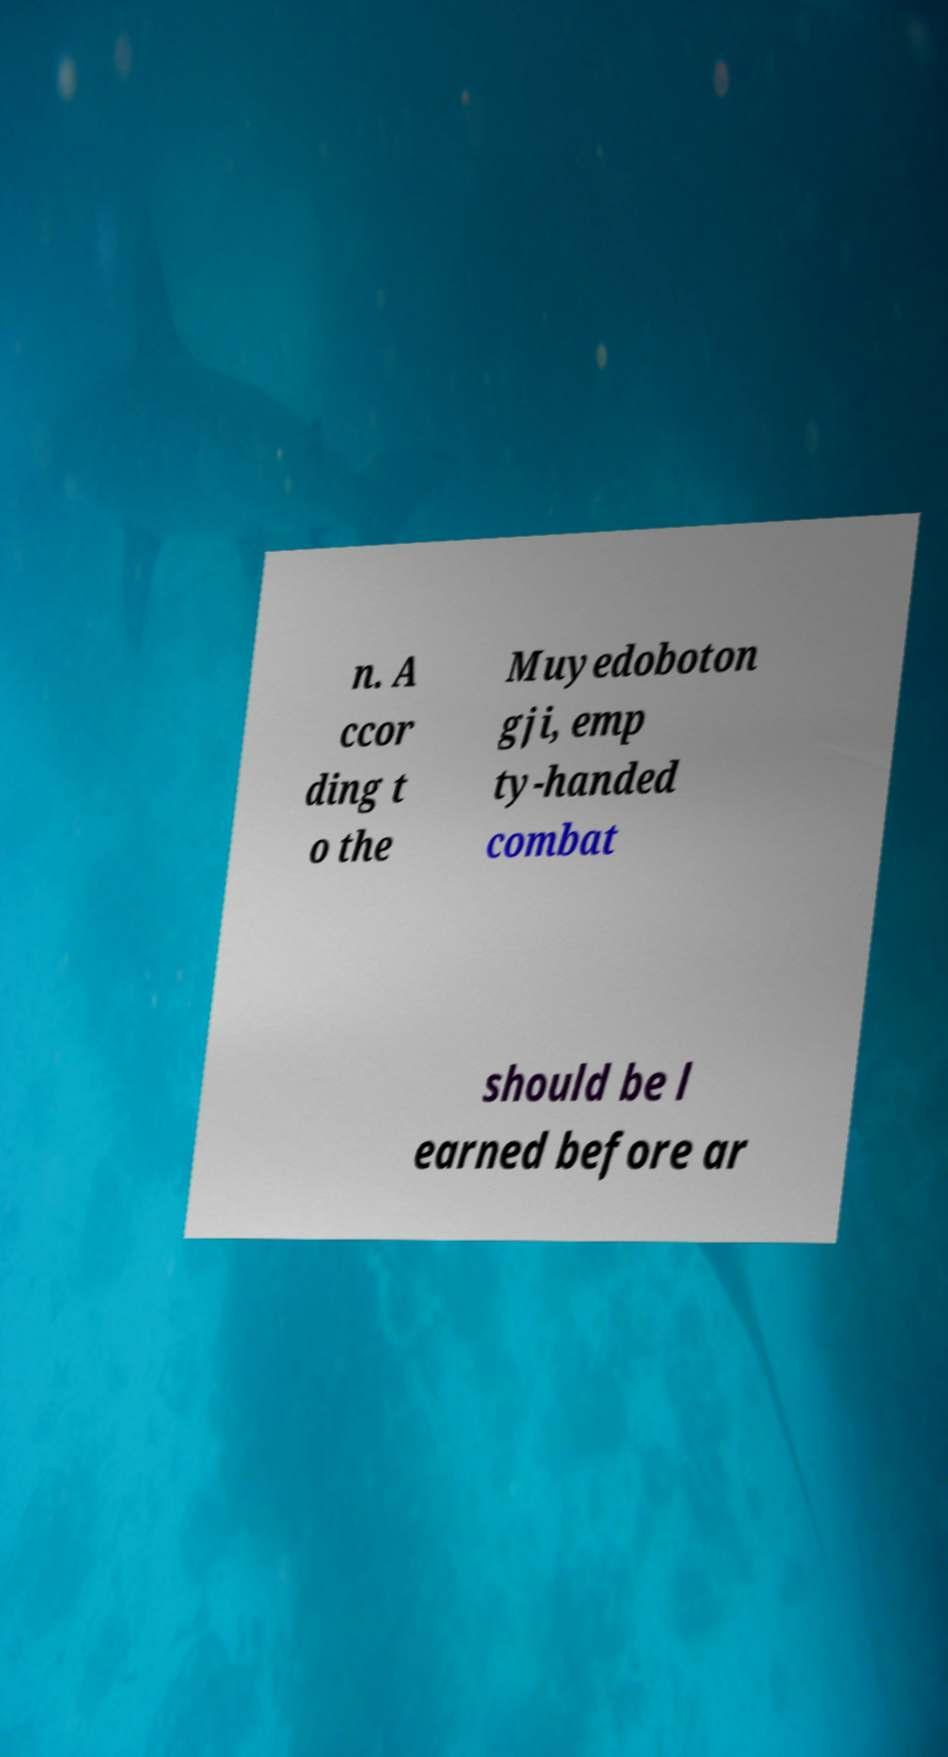For documentation purposes, I need the text within this image transcribed. Could you provide that? n. A ccor ding t o the Muyedoboton gji, emp ty-handed combat should be l earned before ar 